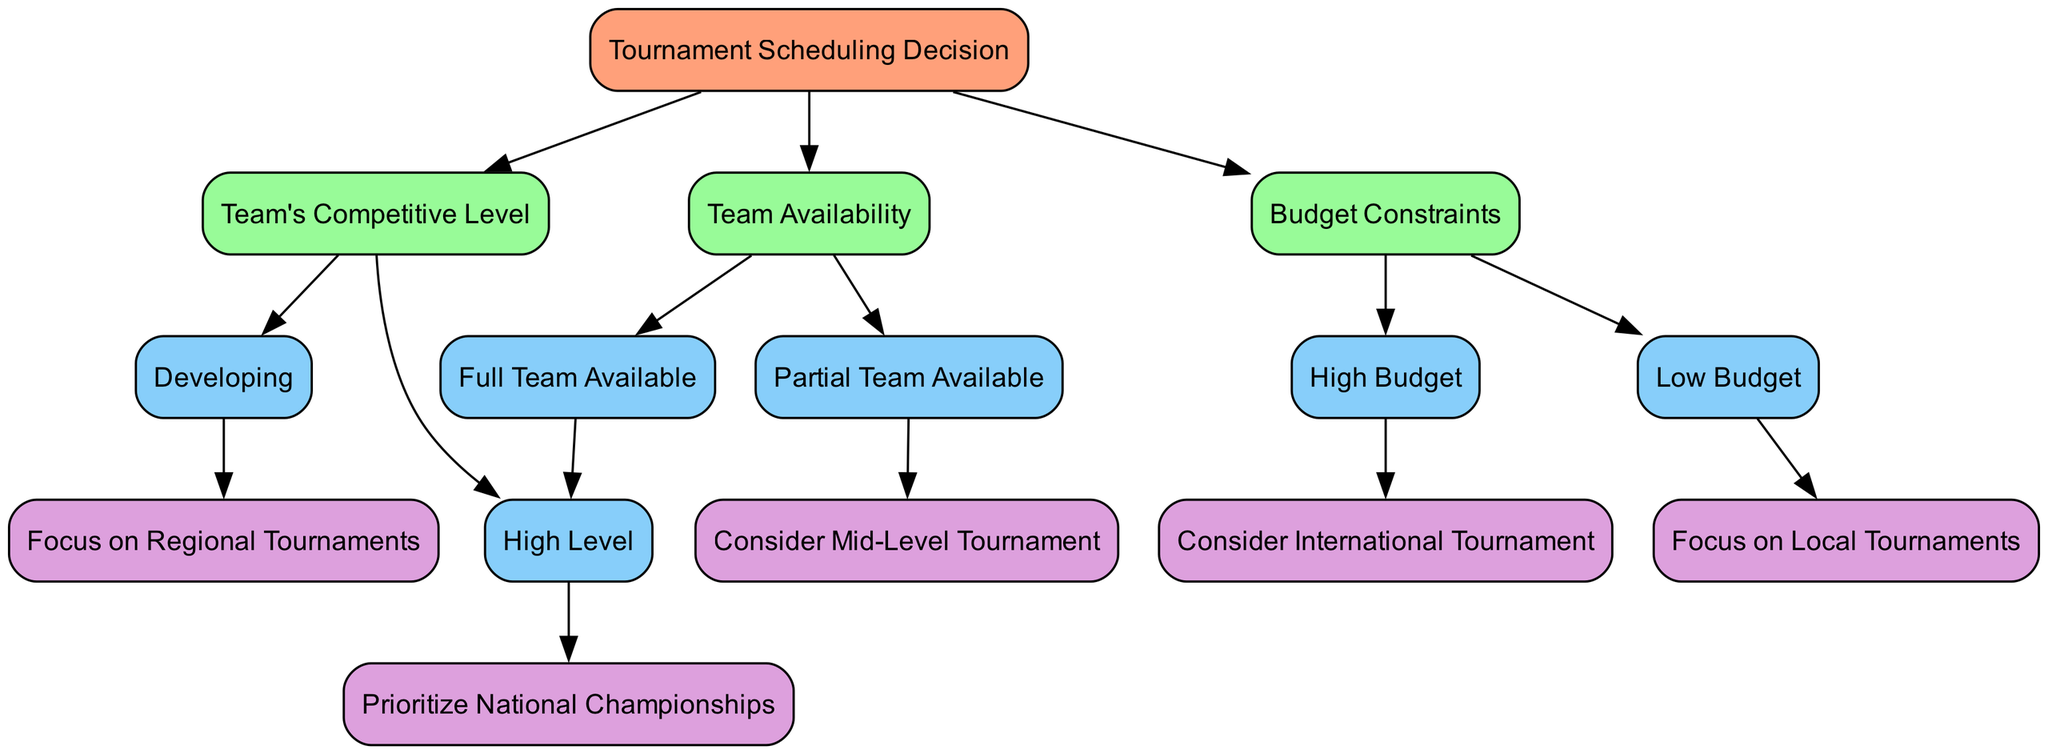What is the first decision point in the tree? The first decision point in the tree is "Tournament Scheduling Decision," which serves as the root node from which all other nodes branch out.
Answer: Tournament Scheduling Decision How many main branches are there under Team Availability? There are two main branches under Team Availability: "Full Team Available" and "Partial Team Available."
Answer: Two What type of tournaments does a full team availability lead to? When a full team is available, it leads to the decision of entering a "High-Level Tournament."
Answer: High-Level Tournament What is the outcome if the budget is low? If the budget is low, the focus will be on "Local Tournaments," making it the outcome at that decision point.
Answer: Local Tournaments If the team is developing, what tournament should they focus on? A developing team should focus on "Regional Tournaments," as indicated in the tree under the relevant decision point.
Answer: Regional Tournaments What is the relationship between high budget and international tournaments? The relationship is that a high budget allows consideration for "International Tournaments" as part of the tournament scheduling decision.
Answer: High budget allows international tournaments If the team is available partially and has a low budget, what should be prioritized? The flow suggests prioritizing "Mid-Level Tournament" under "Partial Team Available," but the low budget does not lead to any direct decision. However, it does not cancel the mid-level option.
Answer: Mid-Level Tournament What do we decide if the team is of a high competitive level? If the team is of a high competitive level, we prioritize "National Championships," which is the conclusion reached at that decision node.
Answer: National Championships How many total nodes are in the decision tree? The total number of nodes in the decision tree, including the root and all children, is nine.
Answer: Nine 